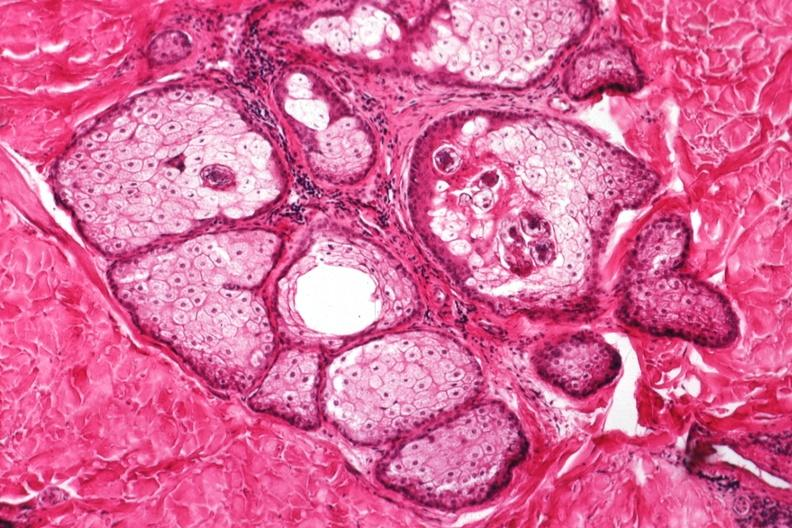s demodex folliculorum present?
Answer the question using a single word or phrase. Yes 